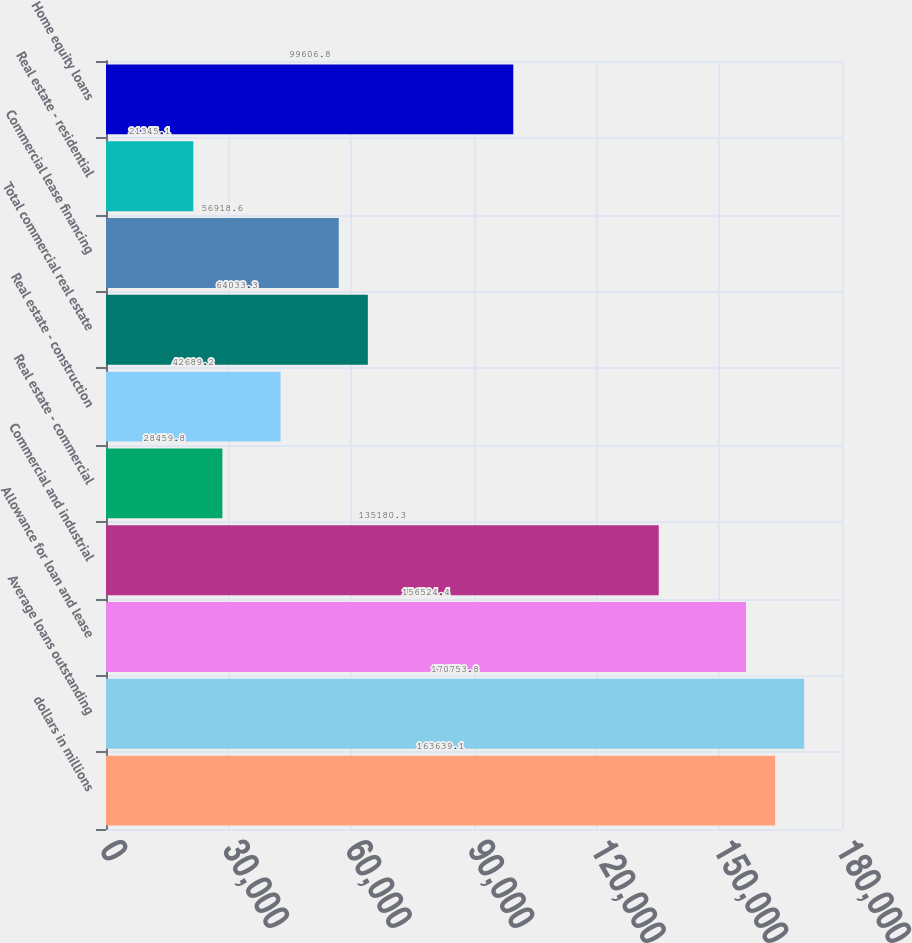Convert chart to OTSL. <chart><loc_0><loc_0><loc_500><loc_500><bar_chart><fcel>dollars in millions<fcel>Average loans outstanding<fcel>Allowance for loan and lease<fcel>Commercial and industrial<fcel>Real estate - commercial<fcel>Real estate - construction<fcel>Total commercial real estate<fcel>Commercial lease financing<fcel>Real estate - residential<fcel>Home equity loans<nl><fcel>163639<fcel>170754<fcel>156524<fcel>135180<fcel>28459.8<fcel>42689.2<fcel>64033.3<fcel>56918.6<fcel>21345.1<fcel>99606.8<nl></chart> 